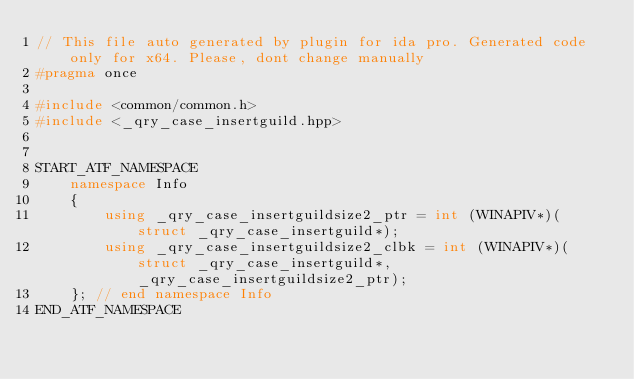Convert code to text. <code><loc_0><loc_0><loc_500><loc_500><_C++_>// This file auto generated by plugin for ida pro. Generated code only for x64. Please, dont change manually
#pragma once

#include <common/common.h>
#include <_qry_case_insertguild.hpp>


START_ATF_NAMESPACE
    namespace Info
    {
        using _qry_case_insertguildsize2_ptr = int (WINAPIV*)(struct _qry_case_insertguild*);
        using _qry_case_insertguildsize2_clbk = int (WINAPIV*)(struct _qry_case_insertguild*, _qry_case_insertguildsize2_ptr);
    }; // end namespace Info
END_ATF_NAMESPACE
</code> 